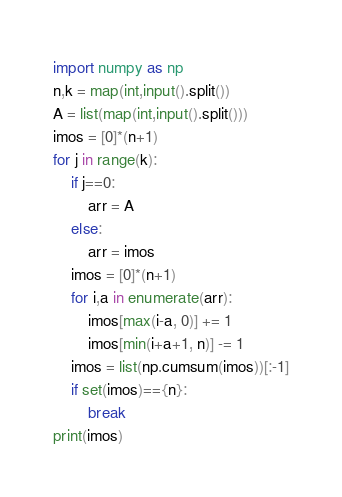Convert code to text. <code><loc_0><loc_0><loc_500><loc_500><_Python_>import numpy as np
n,k = map(int,input().split())
A = list(map(int,input().split()))
imos = [0]*(n+1)
for j in range(k):
    if j==0:
        arr = A
    else:
        arr = imos
    imos = [0]*(n+1)
    for i,a in enumerate(arr):
        imos[max(i-a, 0)] += 1
        imos[min(i+a+1, n)] -= 1
    imos = list(np.cumsum(imos))[:-1]
    if set(imos)=={n}:
        break
print(imos)</code> 